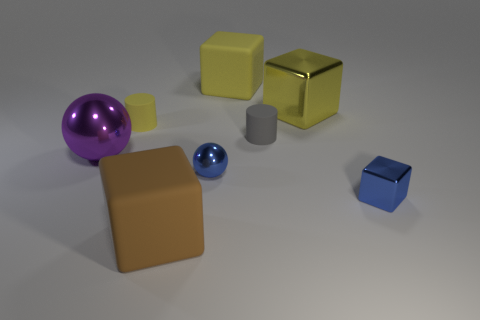Subtract all large brown rubber cubes. How many cubes are left? 3 Subtract all yellow cylinders. How many yellow cubes are left? 2 Add 1 yellow rubber blocks. How many objects exist? 9 Subtract all yellow cubes. How many cubes are left? 2 Subtract 1 blocks. How many blocks are left? 3 Subtract all cylinders. How many objects are left? 6 Subtract all blue cubes. Subtract all green cylinders. How many cubes are left? 3 Subtract 0 gray spheres. How many objects are left? 8 Subtract all purple shiny things. Subtract all yellow cubes. How many objects are left? 5 Add 4 small gray rubber objects. How many small gray rubber objects are left? 5 